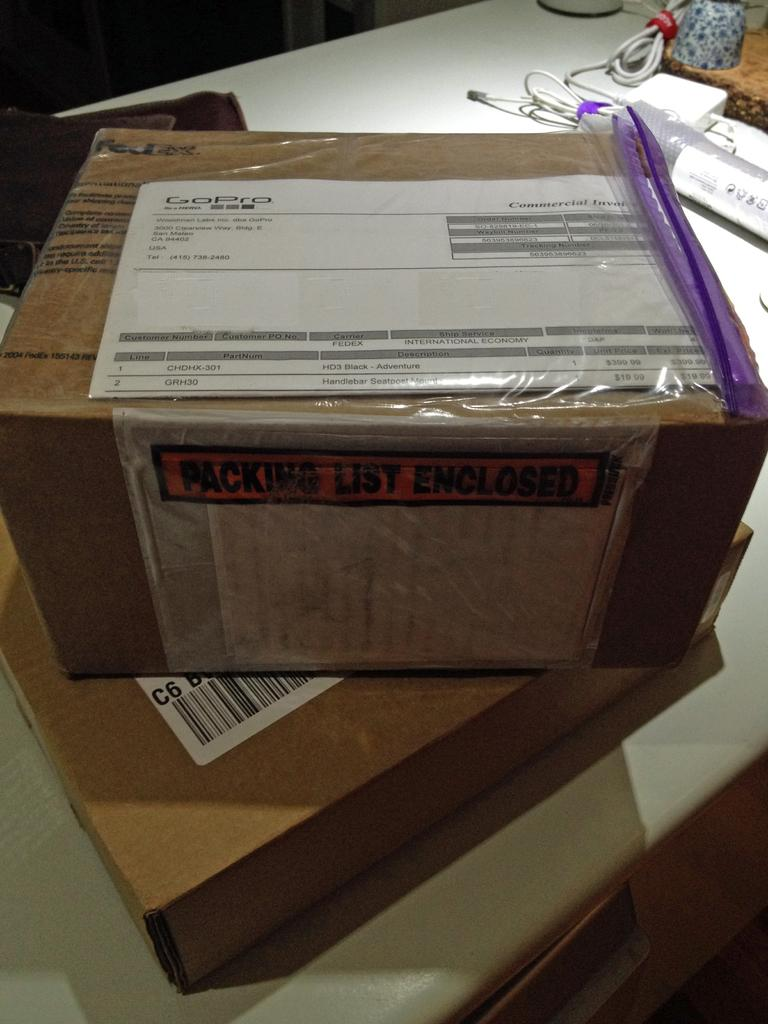<image>
Give a short and clear explanation of the subsequent image. The box appears to be from GoPro company. 